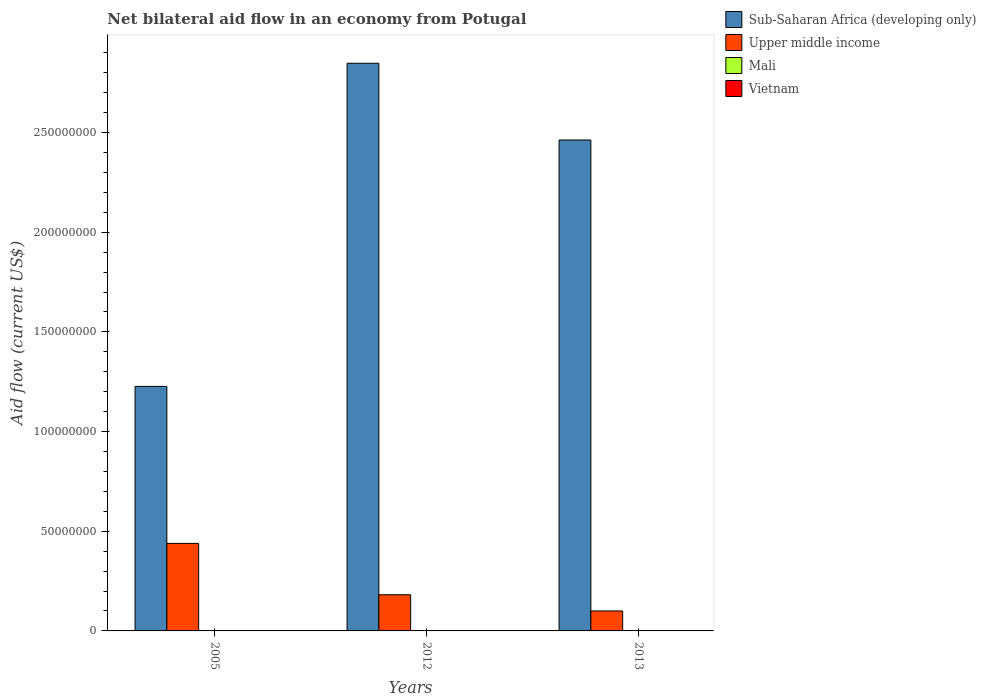How many different coloured bars are there?
Make the answer very short. 4. How many groups of bars are there?
Ensure brevity in your answer.  3. What is the label of the 2nd group of bars from the left?
Your response must be concise. 2012. What is the net bilateral aid flow in Sub-Saharan Africa (developing only) in 2013?
Your answer should be compact. 2.46e+08. Across all years, what is the maximum net bilateral aid flow in Sub-Saharan Africa (developing only)?
Your answer should be very brief. 2.85e+08. Across all years, what is the minimum net bilateral aid flow in Upper middle income?
Give a very brief answer. 1.00e+07. In which year was the net bilateral aid flow in Upper middle income minimum?
Ensure brevity in your answer.  2013. What is the total net bilateral aid flow in Upper middle income in the graph?
Your answer should be compact. 7.21e+07. What is the difference between the net bilateral aid flow in Vietnam in 2005 and that in 2012?
Provide a short and direct response. -10000. What is the difference between the net bilateral aid flow in Upper middle income in 2005 and the net bilateral aid flow in Vietnam in 2012?
Offer a terse response. 4.39e+07. What is the average net bilateral aid flow in Sub-Saharan Africa (developing only) per year?
Keep it short and to the point. 2.18e+08. In the year 2012, what is the difference between the net bilateral aid flow in Sub-Saharan Africa (developing only) and net bilateral aid flow in Mali?
Make the answer very short. 2.85e+08. What is the ratio of the net bilateral aid flow in Vietnam in 2005 to that in 2013?
Your response must be concise. 0.33. Is the net bilateral aid flow in Mali in 2005 less than that in 2012?
Make the answer very short. No. Is the difference between the net bilateral aid flow in Sub-Saharan Africa (developing only) in 2005 and 2013 greater than the difference between the net bilateral aid flow in Mali in 2005 and 2013?
Ensure brevity in your answer.  No. What is the difference between the highest and the second highest net bilateral aid flow in Upper middle income?
Your answer should be compact. 2.58e+07. What is the difference between the highest and the lowest net bilateral aid flow in Vietnam?
Your response must be concise. 2.00e+04. Is the sum of the net bilateral aid flow in Upper middle income in 2005 and 2013 greater than the maximum net bilateral aid flow in Mali across all years?
Offer a terse response. Yes. Is it the case that in every year, the sum of the net bilateral aid flow in Sub-Saharan Africa (developing only) and net bilateral aid flow in Vietnam is greater than the sum of net bilateral aid flow in Mali and net bilateral aid flow in Upper middle income?
Your answer should be compact. Yes. What does the 1st bar from the left in 2005 represents?
Your answer should be compact. Sub-Saharan Africa (developing only). What does the 3rd bar from the right in 2013 represents?
Ensure brevity in your answer.  Upper middle income. Is it the case that in every year, the sum of the net bilateral aid flow in Mali and net bilateral aid flow in Sub-Saharan Africa (developing only) is greater than the net bilateral aid flow in Vietnam?
Provide a short and direct response. Yes. How many bars are there?
Ensure brevity in your answer.  12. What is the difference between two consecutive major ticks on the Y-axis?
Your answer should be very brief. 5.00e+07. Are the values on the major ticks of Y-axis written in scientific E-notation?
Provide a succinct answer. No. Does the graph contain grids?
Your response must be concise. No. Where does the legend appear in the graph?
Provide a succinct answer. Top right. What is the title of the graph?
Provide a succinct answer. Net bilateral aid flow in an economy from Potugal. Does "Ecuador" appear as one of the legend labels in the graph?
Provide a short and direct response. No. What is the label or title of the X-axis?
Your answer should be compact. Years. What is the label or title of the Y-axis?
Offer a very short reply. Aid flow (current US$). What is the Aid flow (current US$) in Sub-Saharan Africa (developing only) in 2005?
Your answer should be very brief. 1.23e+08. What is the Aid flow (current US$) of Upper middle income in 2005?
Your answer should be compact. 4.39e+07. What is the Aid flow (current US$) of Sub-Saharan Africa (developing only) in 2012?
Provide a succinct answer. 2.85e+08. What is the Aid flow (current US$) of Upper middle income in 2012?
Give a very brief answer. 1.81e+07. What is the Aid flow (current US$) in Mali in 2012?
Keep it short and to the point. 10000. What is the Aid flow (current US$) in Sub-Saharan Africa (developing only) in 2013?
Make the answer very short. 2.46e+08. What is the Aid flow (current US$) in Upper middle income in 2013?
Offer a terse response. 1.00e+07. Across all years, what is the maximum Aid flow (current US$) of Sub-Saharan Africa (developing only)?
Offer a very short reply. 2.85e+08. Across all years, what is the maximum Aid flow (current US$) of Upper middle income?
Make the answer very short. 4.39e+07. Across all years, what is the minimum Aid flow (current US$) of Sub-Saharan Africa (developing only)?
Provide a short and direct response. 1.23e+08. Across all years, what is the minimum Aid flow (current US$) in Upper middle income?
Make the answer very short. 1.00e+07. Across all years, what is the minimum Aid flow (current US$) in Mali?
Provide a succinct answer. 10000. Across all years, what is the minimum Aid flow (current US$) of Vietnam?
Offer a very short reply. 10000. What is the total Aid flow (current US$) in Sub-Saharan Africa (developing only) in the graph?
Provide a succinct answer. 6.54e+08. What is the total Aid flow (current US$) in Upper middle income in the graph?
Offer a very short reply. 7.21e+07. What is the total Aid flow (current US$) in Vietnam in the graph?
Make the answer very short. 6.00e+04. What is the difference between the Aid flow (current US$) in Sub-Saharan Africa (developing only) in 2005 and that in 2012?
Ensure brevity in your answer.  -1.62e+08. What is the difference between the Aid flow (current US$) in Upper middle income in 2005 and that in 2012?
Offer a terse response. 2.58e+07. What is the difference between the Aid flow (current US$) in Vietnam in 2005 and that in 2012?
Ensure brevity in your answer.  -10000. What is the difference between the Aid flow (current US$) of Sub-Saharan Africa (developing only) in 2005 and that in 2013?
Offer a terse response. -1.24e+08. What is the difference between the Aid flow (current US$) in Upper middle income in 2005 and that in 2013?
Offer a terse response. 3.39e+07. What is the difference between the Aid flow (current US$) of Mali in 2005 and that in 2013?
Provide a short and direct response. -2.00e+04. What is the difference between the Aid flow (current US$) in Sub-Saharan Africa (developing only) in 2012 and that in 2013?
Offer a terse response. 3.85e+07. What is the difference between the Aid flow (current US$) in Upper middle income in 2012 and that in 2013?
Offer a very short reply. 8.12e+06. What is the difference between the Aid flow (current US$) of Mali in 2012 and that in 2013?
Your answer should be compact. -3.00e+04. What is the difference between the Aid flow (current US$) in Vietnam in 2012 and that in 2013?
Make the answer very short. -10000. What is the difference between the Aid flow (current US$) of Sub-Saharan Africa (developing only) in 2005 and the Aid flow (current US$) of Upper middle income in 2012?
Your answer should be compact. 1.05e+08. What is the difference between the Aid flow (current US$) of Sub-Saharan Africa (developing only) in 2005 and the Aid flow (current US$) of Mali in 2012?
Your answer should be very brief. 1.23e+08. What is the difference between the Aid flow (current US$) in Sub-Saharan Africa (developing only) in 2005 and the Aid flow (current US$) in Vietnam in 2012?
Provide a succinct answer. 1.23e+08. What is the difference between the Aid flow (current US$) in Upper middle income in 2005 and the Aid flow (current US$) in Mali in 2012?
Your answer should be compact. 4.39e+07. What is the difference between the Aid flow (current US$) of Upper middle income in 2005 and the Aid flow (current US$) of Vietnam in 2012?
Make the answer very short. 4.39e+07. What is the difference between the Aid flow (current US$) in Sub-Saharan Africa (developing only) in 2005 and the Aid flow (current US$) in Upper middle income in 2013?
Offer a terse response. 1.13e+08. What is the difference between the Aid flow (current US$) in Sub-Saharan Africa (developing only) in 2005 and the Aid flow (current US$) in Mali in 2013?
Offer a terse response. 1.23e+08. What is the difference between the Aid flow (current US$) of Sub-Saharan Africa (developing only) in 2005 and the Aid flow (current US$) of Vietnam in 2013?
Keep it short and to the point. 1.23e+08. What is the difference between the Aid flow (current US$) in Upper middle income in 2005 and the Aid flow (current US$) in Mali in 2013?
Make the answer very short. 4.39e+07. What is the difference between the Aid flow (current US$) in Upper middle income in 2005 and the Aid flow (current US$) in Vietnam in 2013?
Give a very brief answer. 4.39e+07. What is the difference between the Aid flow (current US$) in Sub-Saharan Africa (developing only) in 2012 and the Aid flow (current US$) in Upper middle income in 2013?
Your answer should be very brief. 2.75e+08. What is the difference between the Aid flow (current US$) in Sub-Saharan Africa (developing only) in 2012 and the Aid flow (current US$) in Mali in 2013?
Make the answer very short. 2.85e+08. What is the difference between the Aid flow (current US$) in Sub-Saharan Africa (developing only) in 2012 and the Aid flow (current US$) in Vietnam in 2013?
Offer a very short reply. 2.85e+08. What is the difference between the Aid flow (current US$) of Upper middle income in 2012 and the Aid flow (current US$) of Mali in 2013?
Offer a very short reply. 1.81e+07. What is the difference between the Aid flow (current US$) of Upper middle income in 2012 and the Aid flow (current US$) of Vietnam in 2013?
Provide a succinct answer. 1.81e+07. What is the difference between the Aid flow (current US$) in Mali in 2012 and the Aid flow (current US$) in Vietnam in 2013?
Make the answer very short. -2.00e+04. What is the average Aid flow (current US$) in Sub-Saharan Africa (developing only) per year?
Provide a short and direct response. 2.18e+08. What is the average Aid flow (current US$) in Upper middle income per year?
Your response must be concise. 2.40e+07. What is the average Aid flow (current US$) in Mali per year?
Ensure brevity in your answer.  2.33e+04. In the year 2005, what is the difference between the Aid flow (current US$) of Sub-Saharan Africa (developing only) and Aid flow (current US$) of Upper middle income?
Your answer should be very brief. 7.88e+07. In the year 2005, what is the difference between the Aid flow (current US$) in Sub-Saharan Africa (developing only) and Aid flow (current US$) in Mali?
Provide a succinct answer. 1.23e+08. In the year 2005, what is the difference between the Aid flow (current US$) of Sub-Saharan Africa (developing only) and Aid flow (current US$) of Vietnam?
Your answer should be compact. 1.23e+08. In the year 2005, what is the difference between the Aid flow (current US$) of Upper middle income and Aid flow (current US$) of Mali?
Your answer should be very brief. 4.39e+07. In the year 2005, what is the difference between the Aid flow (current US$) in Upper middle income and Aid flow (current US$) in Vietnam?
Provide a short and direct response. 4.39e+07. In the year 2005, what is the difference between the Aid flow (current US$) in Mali and Aid flow (current US$) in Vietnam?
Offer a terse response. 10000. In the year 2012, what is the difference between the Aid flow (current US$) in Sub-Saharan Africa (developing only) and Aid flow (current US$) in Upper middle income?
Keep it short and to the point. 2.67e+08. In the year 2012, what is the difference between the Aid flow (current US$) of Sub-Saharan Africa (developing only) and Aid flow (current US$) of Mali?
Ensure brevity in your answer.  2.85e+08. In the year 2012, what is the difference between the Aid flow (current US$) in Sub-Saharan Africa (developing only) and Aid flow (current US$) in Vietnam?
Your answer should be compact. 2.85e+08. In the year 2012, what is the difference between the Aid flow (current US$) in Upper middle income and Aid flow (current US$) in Mali?
Offer a terse response. 1.81e+07. In the year 2012, what is the difference between the Aid flow (current US$) in Upper middle income and Aid flow (current US$) in Vietnam?
Give a very brief answer. 1.81e+07. In the year 2013, what is the difference between the Aid flow (current US$) of Sub-Saharan Africa (developing only) and Aid flow (current US$) of Upper middle income?
Ensure brevity in your answer.  2.36e+08. In the year 2013, what is the difference between the Aid flow (current US$) of Sub-Saharan Africa (developing only) and Aid flow (current US$) of Mali?
Provide a succinct answer. 2.46e+08. In the year 2013, what is the difference between the Aid flow (current US$) of Sub-Saharan Africa (developing only) and Aid flow (current US$) of Vietnam?
Your answer should be very brief. 2.46e+08. In the year 2013, what is the difference between the Aid flow (current US$) of Upper middle income and Aid flow (current US$) of Mali?
Your answer should be very brief. 9.98e+06. In the year 2013, what is the difference between the Aid flow (current US$) in Upper middle income and Aid flow (current US$) in Vietnam?
Your response must be concise. 9.99e+06. In the year 2013, what is the difference between the Aid flow (current US$) of Mali and Aid flow (current US$) of Vietnam?
Offer a very short reply. 10000. What is the ratio of the Aid flow (current US$) of Sub-Saharan Africa (developing only) in 2005 to that in 2012?
Offer a terse response. 0.43. What is the ratio of the Aid flow (current US$) in Upper middle income in 2005 to that in 2012?
Make the answer very short. 2.42. What is the ratio of the Aid flow (current US$) in Mali in 2005 to that in 2012?
Make the answer very short. 2. What is the ratio of the Aid flow (current US$) in Sub-Saharan Africa (developing only) in 2005 to that in 2013?
Make the answer very short. 0.5. What is the ratio of the Aid flow (current US$) in Upper middle income in 2005 to that in 2013?
Provide a short and direct response. 4.38. What is the ratio of the Aid flow (current US$) of Mali in 2005 to that in 2013?
Give a very brief answer. 0.5. What is the ratio of the Aid flow (current US$) in Sub-Saharan Africa (developing only) in 2012 to that in 2013?
Ensure brevity in your answer.  1.16. What is the ratio of the Aid flow (current US$) in Upper middle income in 2012 to that in 2013?
Ensure brevity in your answer.  1.81. What is the difference between the highest and the second highest Aid flow (current US$) of Sub-Saharan Africa (developing only)?
Your answer should be compact. 3.85e+07. What is the difference between the highest and the second highest Aid flow (current US$) in Upper middle income?
Offer a terse response. 2.58e+07. What is the difference between the highest and the second highest Aid flow (current US$) in Mali?
Keep it short and to the point. 2.00e+04. What is the difference between the highest and the lowest Aid flow (current US$) in Sub-Saharan Africa (developing only)?
Provide a succinct answer. 1.62e+08. What is the difference between the highest and the lowest Aid flow (current US$) in Upper middle income?
Provide a short and direct response. 3.39e+07. 